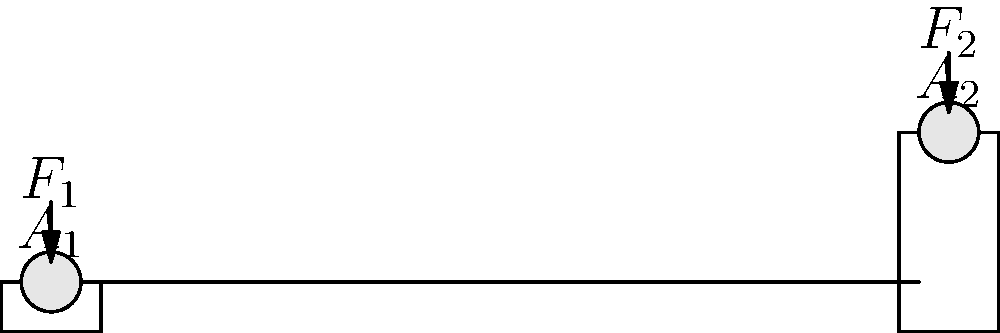Imagine you're trying to lift a heavy box using a simple machine that looks like two connected water tanks. The smaller tank has an area of 10 square inches, and you push down on it with 50 pounds of force. If the larger tank has an area of 100 square inches, how much weight can you lift with this contraption? Let's break this down step-by-step:

1. This "contraption" is actually a hydraulic press, which works based on Pascal's law.

2. Pascal's law states that pressure is transmitted equally in all directions in a confined fluid.

3. In a hydraulic press, the pressure in both cylinders is the same. We can express this as:

   $$\frac{F_1}{A_1} = \frac{F_2}{A_2}$$

   Where $F_1$ and $A_1$ are the force and area of the smaller piston, and $F_2$ and $A_2$ are the force and area of the larger piston.

4. We're given:
   $A_1 = 10$ square inches
   $F_1 = 50$ pounds
   $A_2 = 100$ square inches
   
5. We need to find $F_2$. Let's rearrange the equation:

   $$F_2 = F_1 \times \frac{A_2}{A_1}$$

6. Now, let's plug in the numbers:

   $$F_2 = 50 \times \frac{100}{10} = 50 \times 10 = 500$$

7. Therefore, the force on the larger piston (which is the weight you can lift) is 500 pounds.
Answer: 500 pounds 